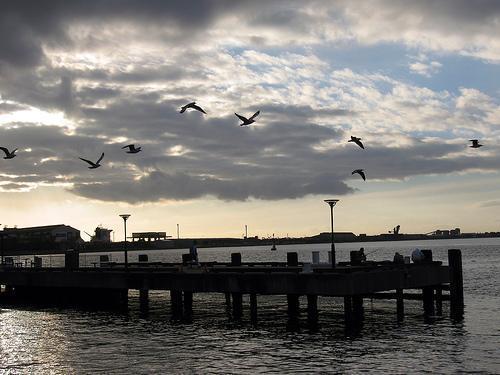How many street lamps are there?
Give a very brief answer. 2. 